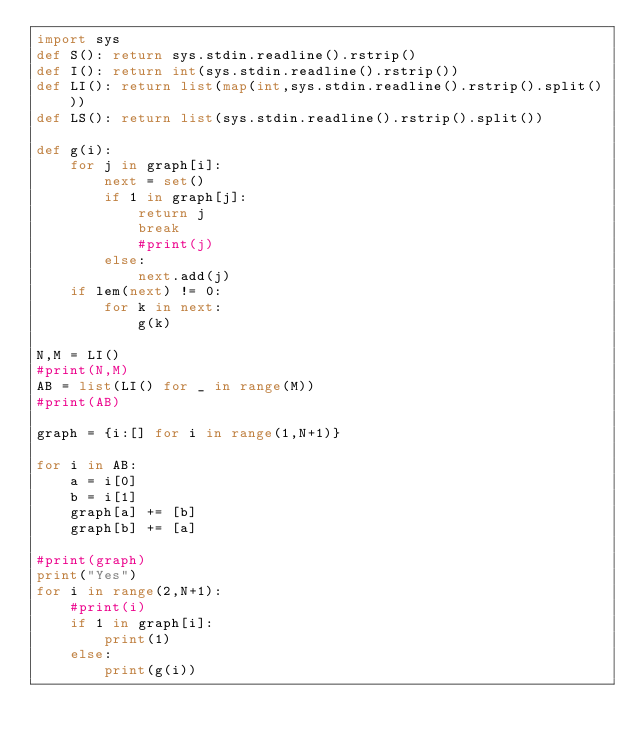Convert code to text. <code><loc_0><loc_0><loc_500><loc_500><_Python_>import sys
def S(): return sys.stdin.readline().rstrip()
def I(): return int(sys.stdin.readline().rstrip())
def LI(): return list(map(int,sys.stdin.readline().rstrip().split()))
def LS(): return list(sys.stdin.readline().rstrip().split())

def g(i):
    for j in graph[i]:
        next = set()
        if 1 in graph[j]:
            return j
            break
            #print(j)
        else:
            next.add(j)
    if lem(next) != 0:
        for k in next:
            g(k)

N,M = LI()
#print(N,M)
AB = list(LI() for _ in range(M))
#print(AB)

graph = {i:[] for i in range(1,N+1)}

for i in AB:
    a = i[0]
    b = i[1]
    graph[a] += [b]
    graph[b] += [a]

#print(graph)
print("Yes")
for i in range(2,N+1):
    #print(i)
    if 1 in graph[i]:
        print(1)
    else:
        print(g(i))
    </code> 